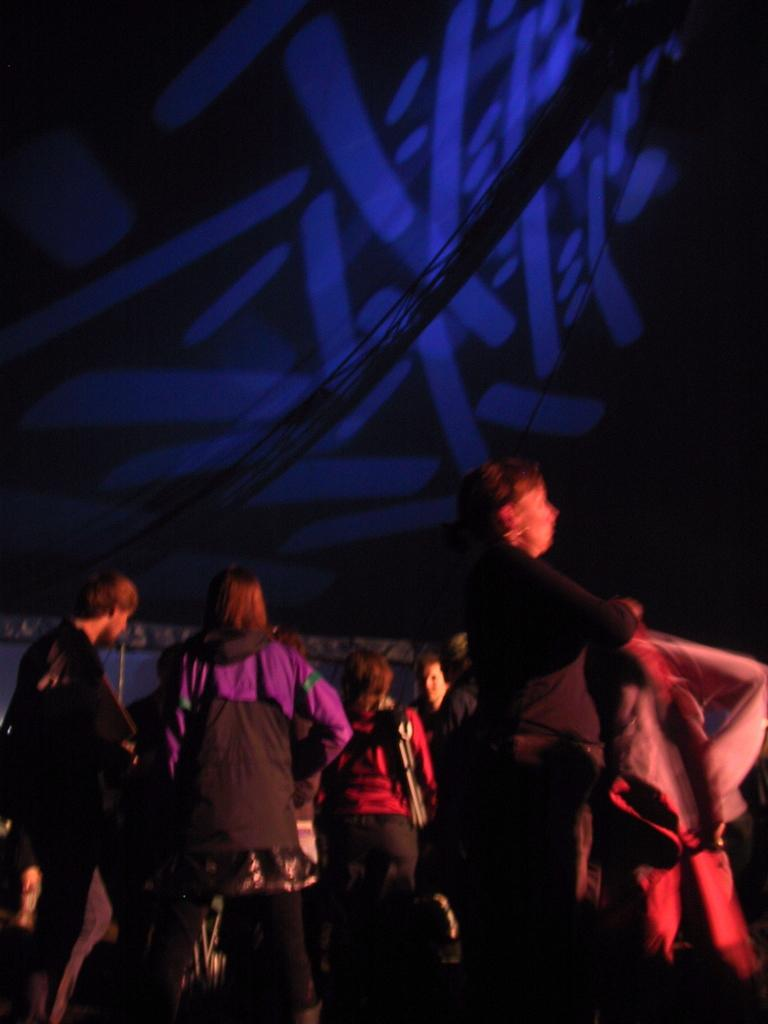What is happening in the image? There is a group of people standing in the image. What can be seen in the background of the image? There is a wall and lights visible in the background of the image. What type of orange can be seen being cut with scissors in the image? There is no orange or scissors present in the image. What verse is being recited by the group of people in the image? There is no indication in the image that the group of people is reciting a verse. 